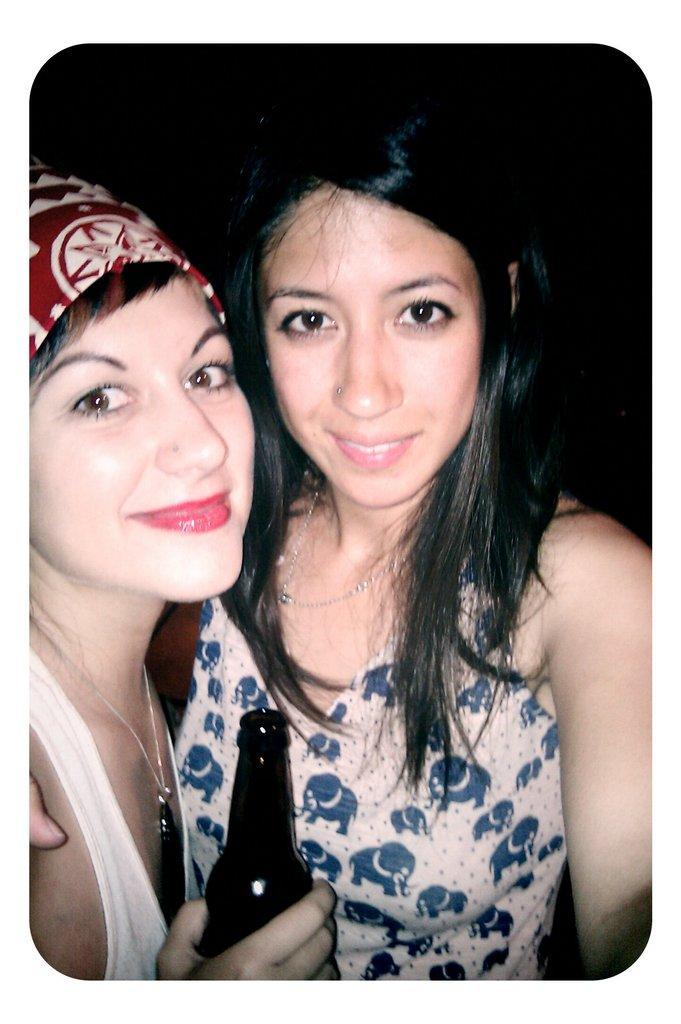Please provide a concise description of this image. In the foreground of this image, there are two women having smile on their face. The woman who is on the left is holding a bottle in her hand and dark background. 